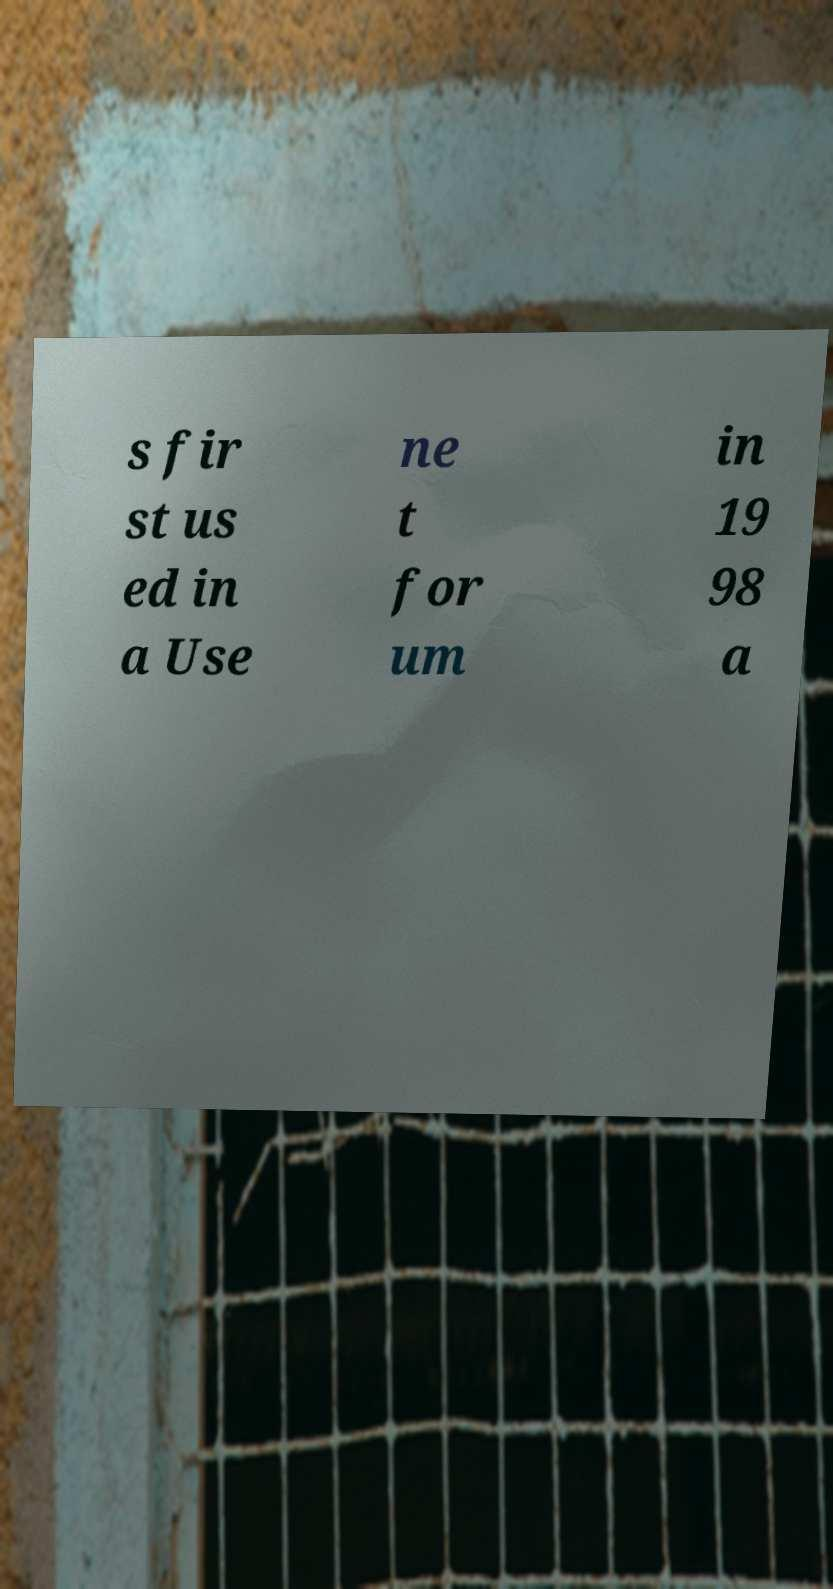What messages or text are displayed in this image? I need them in a readable, typed format. s fir st us ed in a Use ne t for um in 19 98 a 